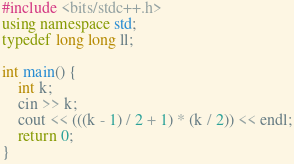Convert code to text. <code><loc_0><loc_0><loc_500><loc_500><_C++_>#include <bits/stdc++.h>
using namespace std;
typedef long long ll;

int main() {
    int k;
    cin >> k;
    cout << (((k - 1) / 2 + 1) * (k / 2)) << endl;
    return 0;
}</code> 